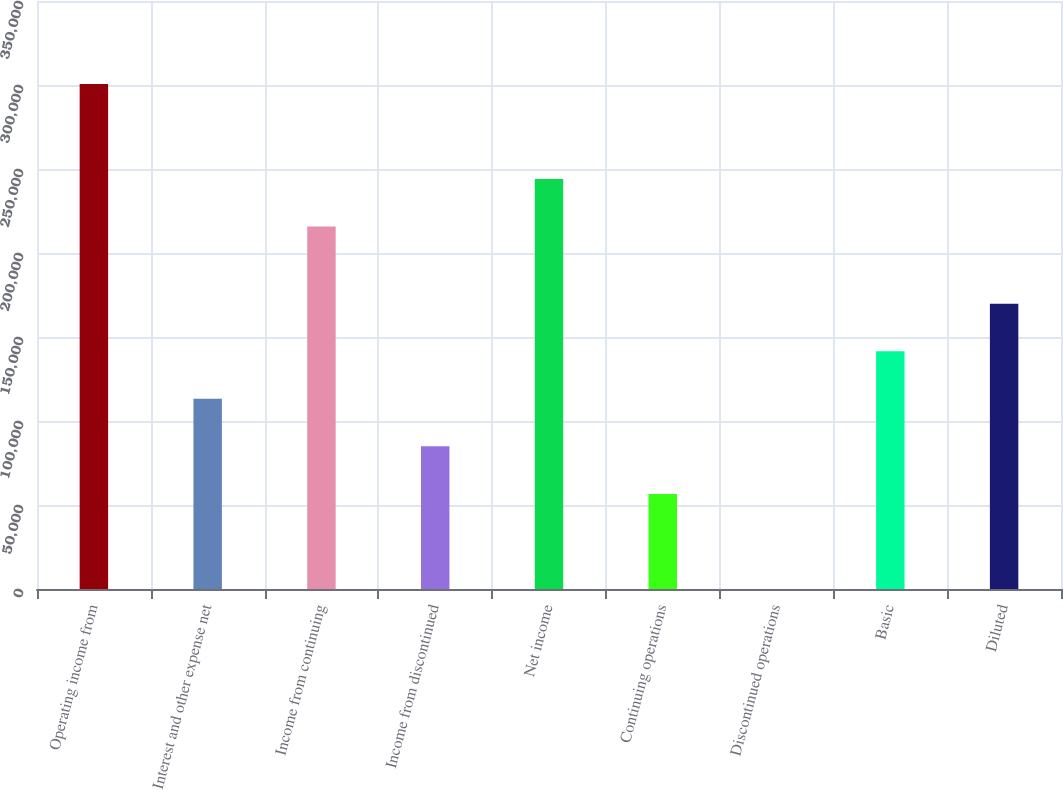Convert chart to OTSL. <chart><loc_0><loc_0><loc_500><loc_500><bar_chart><fcel>Operating income from<fcel>Interest and other expense net<fcel>Income from continuing<fcel>Income from discontinued<fcel>Net income<fcel>Continuing operations<fcel>Discontinued operations<fcel>Basic<fcel>Diluted<nl><fcel>300626<fcel>113226<fcel>215706<fcel>84919.9<fcel>244013<fcel>56613.3<fcel>0.17<fcel>141533<fcel>169840<nl></chart> 